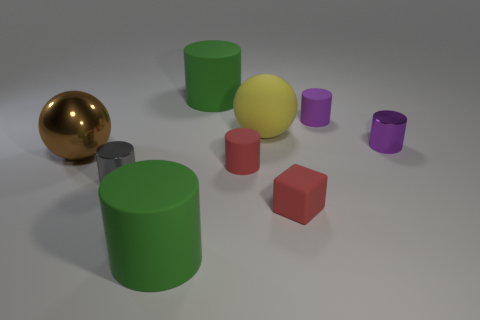Subtract all red rubber cylinders. How many cylinders are left? 5 Subtract all yellow spheres. How many spheres are left? 1 Subtract all balls. How many objects are left? 7 Subtract 4 cylinders. How many cylinders are left? 2 Add 7 green cylinders. How many green cylinders are left? 9 Add 2 green metal cubes. How many green metal cubes exist? 2 Add 1 purple metallic objects. How many objects exist? 10 Subtract 0 green blocks. How many objects are left? 9 Subtract all yellow cubes. Subtract all cyan balls. How many cubes are left? 1 Subtract all purple cylinders. How many gray balls are left? 0 